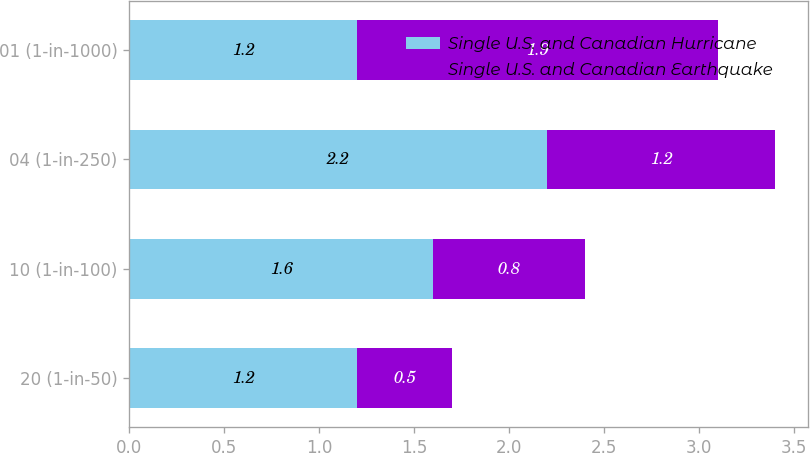<chart> <loc_0><loc_0><loc_500><loc_500><stacked_bar_chart><ecel><fcel>20 (1-in-50)<fcel>10 (1-in-100)<fcel>04 (1-in-250)<fcel>01 (1-in-1000)<nl><fcel>Single U.S. and Canadian Hurricane<fcel>1.2<fcel>1.6<fcel>2.2<fcel>1.2<nl><fcel>Single U.S. and Canadian Earthquake<fcel>0.5<fcel>0.8<fcel>1.2<fcel>1.9<nl></chart> 